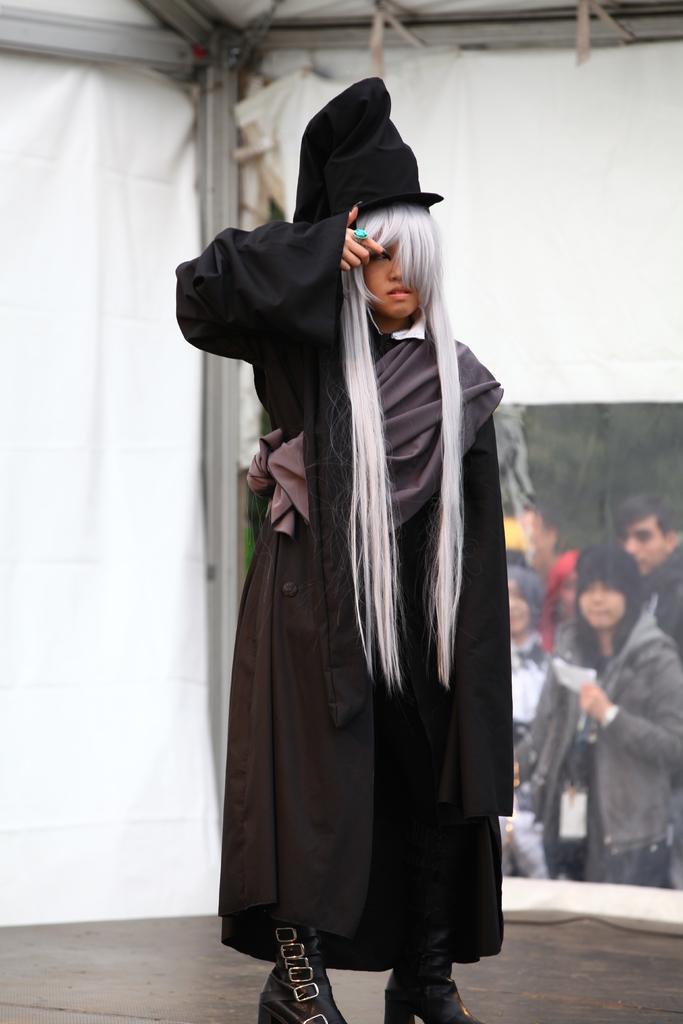How would you summarize this image in a sentence or two? In the foreground I can see a person is standing on the stage in costume. In the background I can see a group of people, trees and a tent. This image is taken may be during a day. 